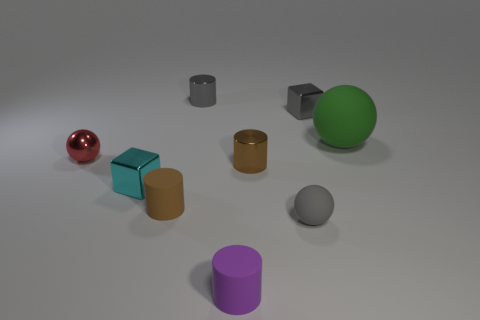Do the big green object and the small red thing have the same material? Based on the image, it appears that the big green ball and the small red sphere might not be made of the same material. The green ball, due to its matte appearance, resembles a surface that could be plastic or rubber, while the small red object has a reflective sheen that suggests it could be metallic or a polished ceramic. 